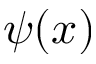<formula> <loc_0><loc_0><loc_500><loc_500>\psi ( x )</formula> 